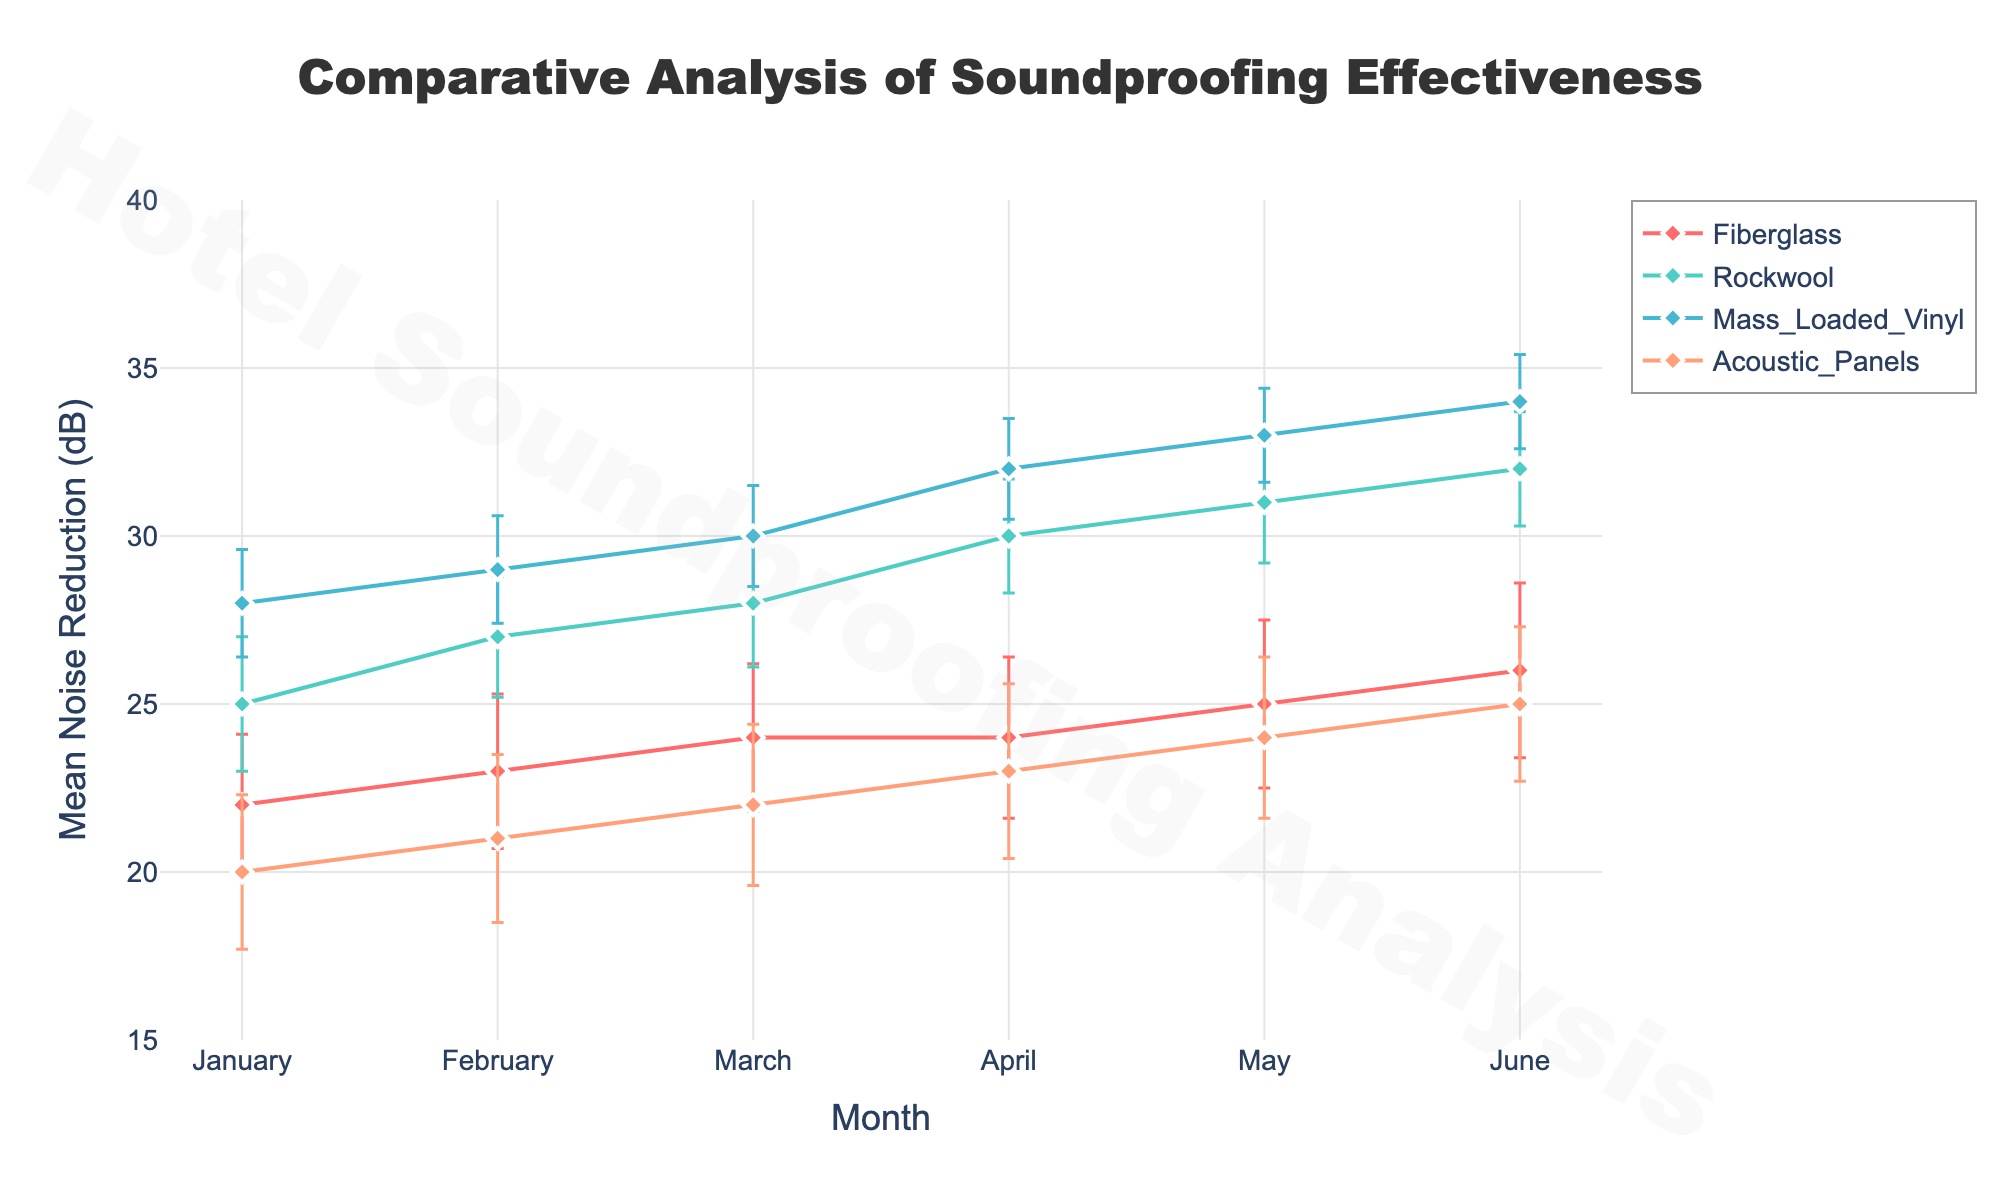How many different materials are represented in the plot? There are four distinct materials represented by different lines and markers in the plot: Fiberglass, Rockwool, Mass Loaded Vinyl, and Acoustic Panels.
Answer: Four What is the title of the plot? The title of the plot is displayed prominently at the top of the figure.
Answer: Comparative Analysis of Soundproofing Effectiveness Which month shows the highest mean noise reduction (dB) for Mass Loaded Vinyl? By following the line for Mass Loaded Vinyl (noting its color and markers) and looking for the position that is the highest on the y-axis, we see that June shows the highest mean noise reduction at 34 dB.
Answer: June What is the mean noise reduction and standard deviation for Rockwool in March? Looking at the Rockwool line and finding the data point for March, the mean noise reduction is 28 dB and the standard deviation is 1.9 dB.
Answer: 28 dB, 1.9 dB Which material shows the most consistent noise reduction (smallest error bars) over the months? Consistent noise reduction is indicated by the smallest error bars. Mass Loaded Vinyl has consistently smaller error bars across all months compared to other materials.
Answer: Mass Loaded Vinyl What is the difference in noise reduction (dB) between Fiberglass and Rockwool in June? Checking the y-axis values for both Fiberglass and Rockwool in June, Fiberglass is at 26 dB and Rockwool is at 32 dB. The difference is 32 - 26 = 6 dB.
Answer: 6 dB How does the noise reduction in May for Acoustic Panels compare to that in January for Mass Loaded Vinyl? Find the y-axis value for Acoustic Panels in May, which is 24 dB, and for Mass Loaded Vinyl in January, which is 28 dB. Comparing these, January's noise reduction for Mass Loaded Vinyl is greater.
Answer: Mass Loaded Vinyl in January is greater What is the average mean noise reduction for Fiberglass from January to June? Add the mean noise reductions for Fiberglass from January (22), February (23), March (24), April (24), May (25), and June (26). Divide by the number of months: (22 + 23 + 24 + 24 + 25 + 26) / 6 = 24 dB.
Answer: 24 dB Compare the trend of noise reduction for Rockwool and Acoustic Panels from January to June. Which one shows a steeper increase? Rockwool starts at 25 dB in January and increases to 32 dB in June, which is an increase of 7 dB. Acoustic Panels start at 20 dB in January and increase to 25 dB in June, which is an increase of 5 dB. Therefore, Rockwool shows a steeper increase.
Answer: Rockwool What is the maximum standard deviation observed for any material and when does it occur? By looking at the error bars' lengths, the maximum standard deviation observed is 2.6 dB for Acoustic Panels in April.
Answer: 2.6 dB in April 